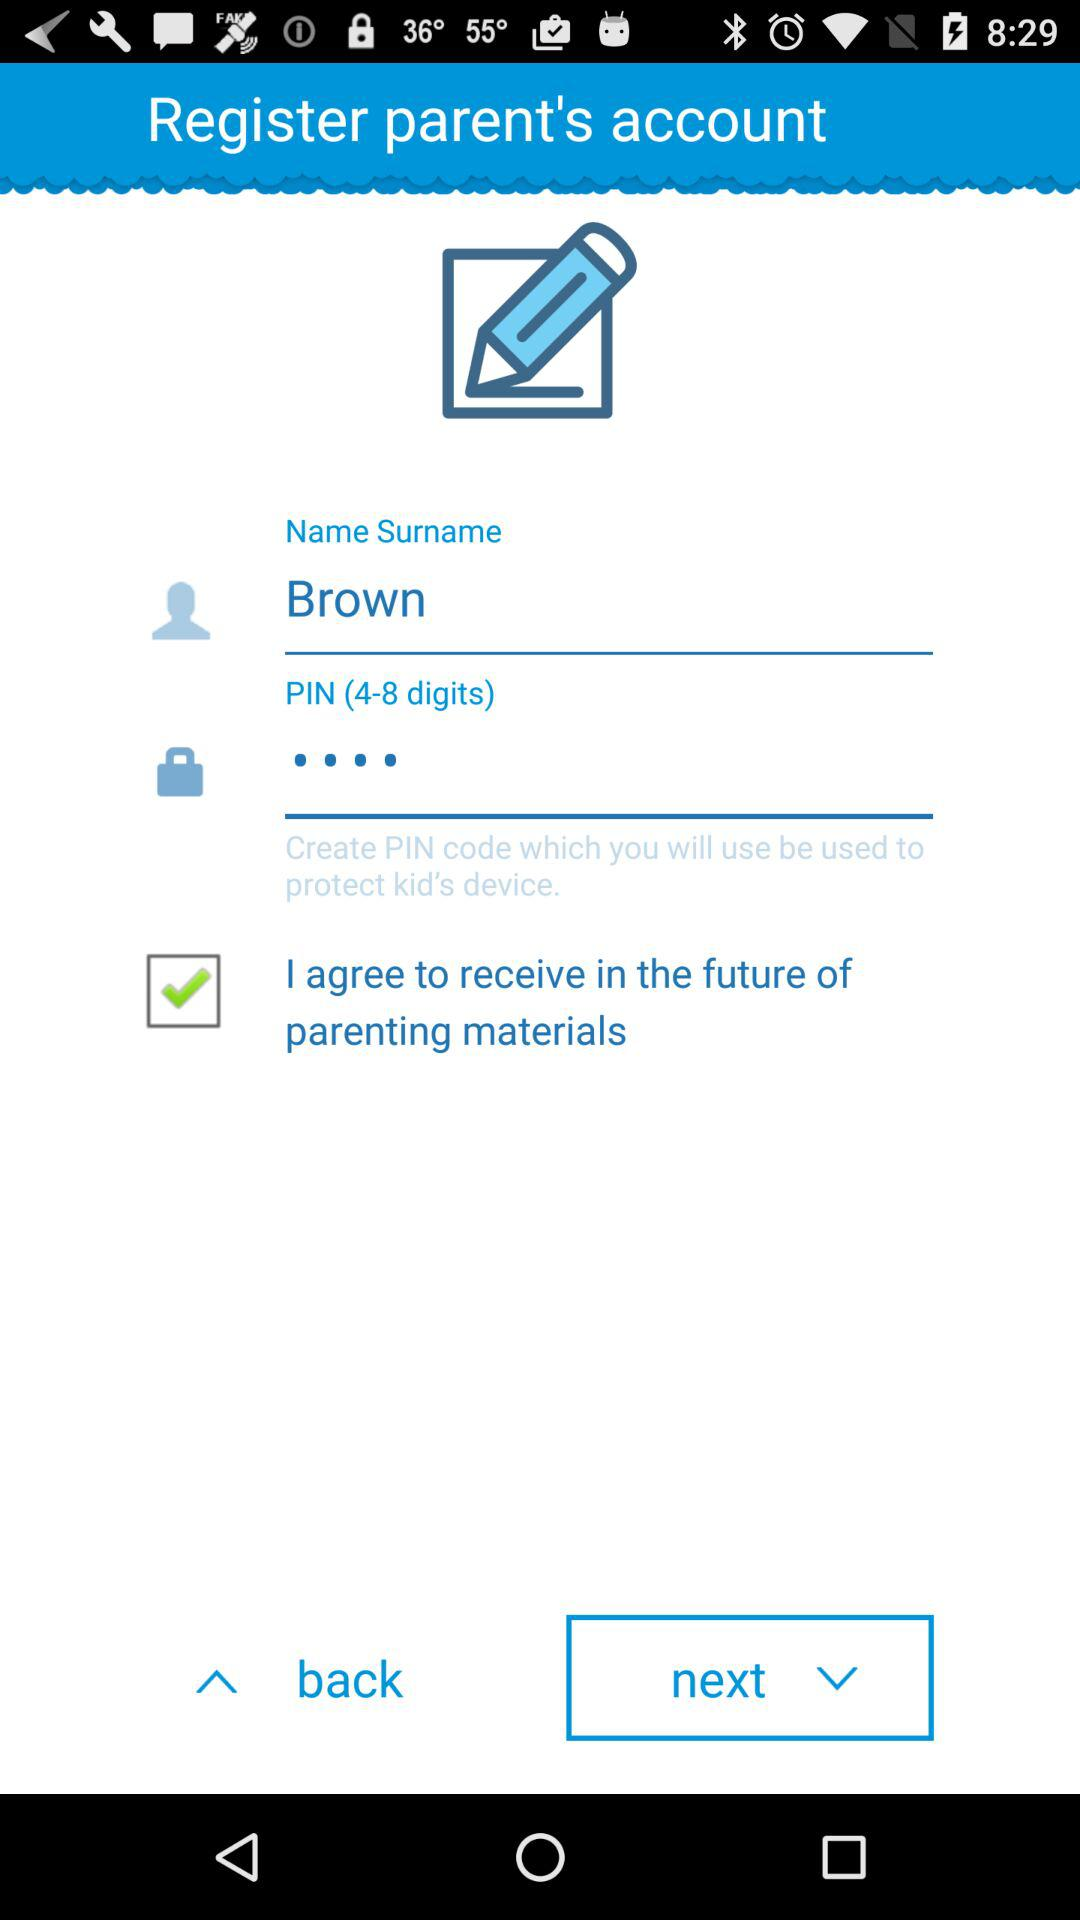What is the name surname? The name surname is Brown. 